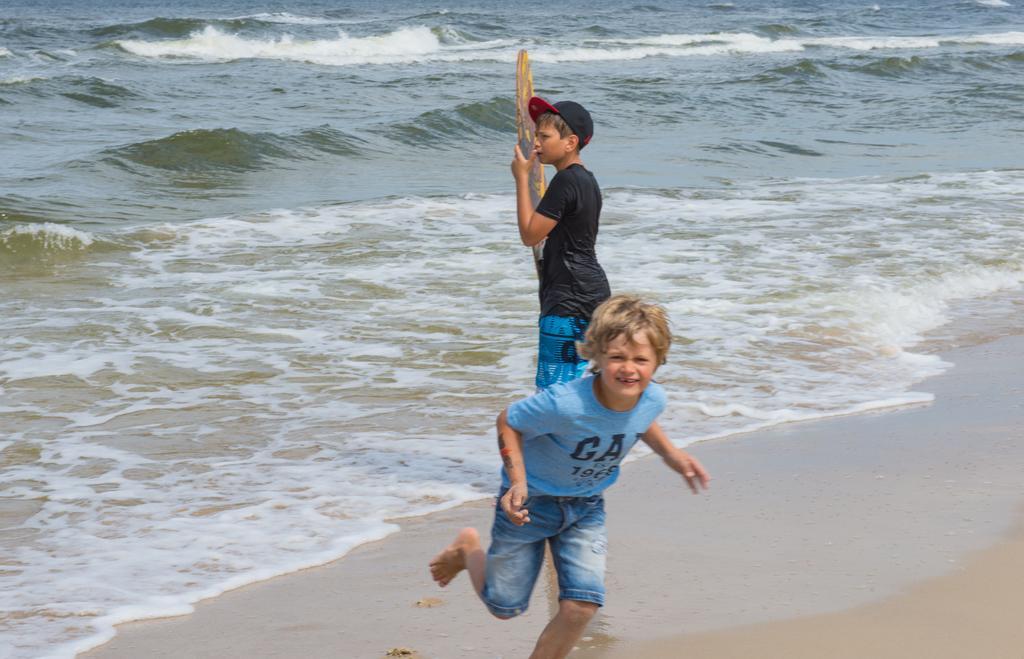How would you summarize this image in a sentence or two? In front of the picture, we see a boy in the blue T-shirt is running. Behind him, we see a boy in the black T-shirt who is wearing a black and red cap is standing and he is holding a wooden stick in his hand. At the bottom, we see the sand. In the background, we see water and this water might be in the sea. 